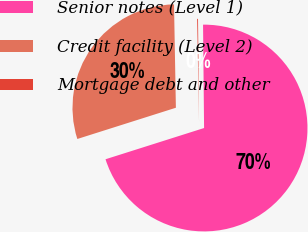Convert chart. <chart><loc_0><loc_0><loc_500><loc_500><pie_chart><fcel>Senior notes (Level 1)<fcel>Credit facility (Level 2)<fcel>Mortgage debt and other<nl><fcel>70.28%<fcel>29.6%<fcel>0.13%<nl></chart> 